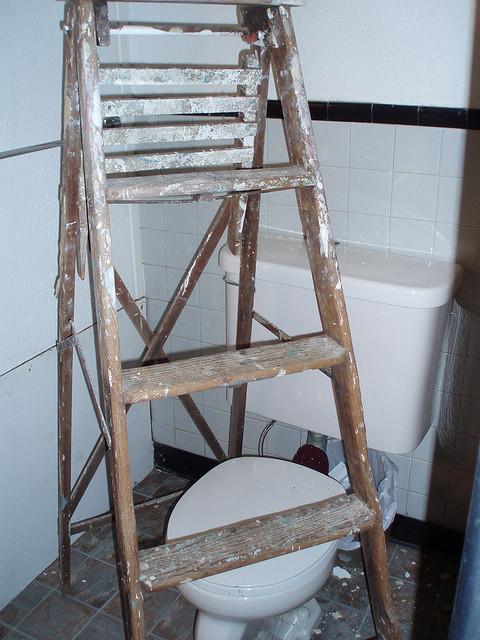Is the toilet been painted?
Write a very short answer. No. What material is the floor made out of?
Answer briefly. Tile. Is the room clean or dirty?
Be succinct. Dirty. 